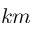Convert formula to latex. <formula><loc_0><loc_0><loc_500><loc_500>k m</formula> 